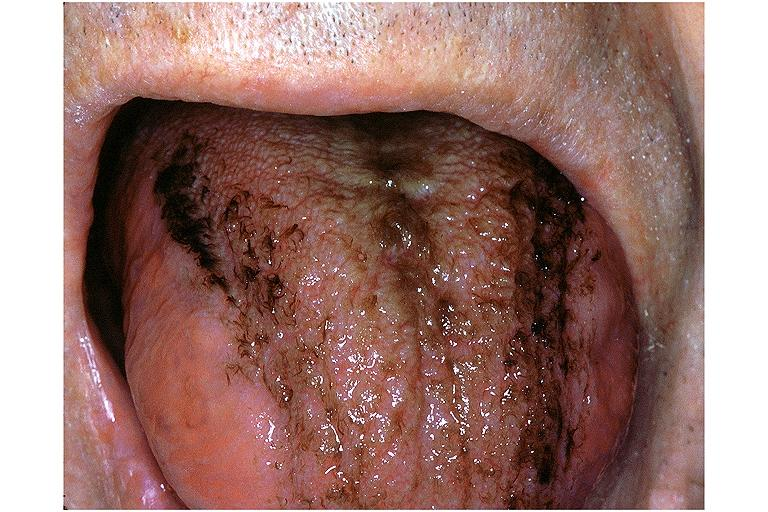s acute inflammation present?
Answer the question using a single word or phrase. No 